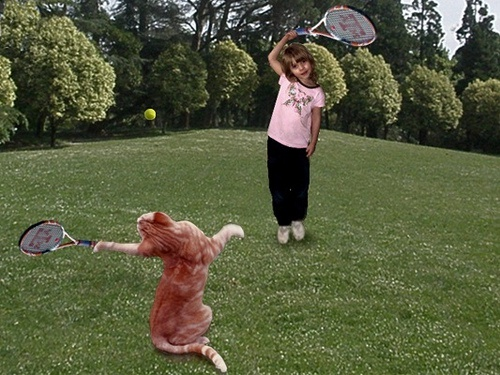Describe the objects in this image and their specific colors. I can see cat in black, maroon, brown, and tan tones, people in black, lightpink, gray, and pink tones, tennis racket in black and gray tones, tennis racket in black, gray, and darkgray tones, and sports ball in black, olive, and khaki tones in this image. 